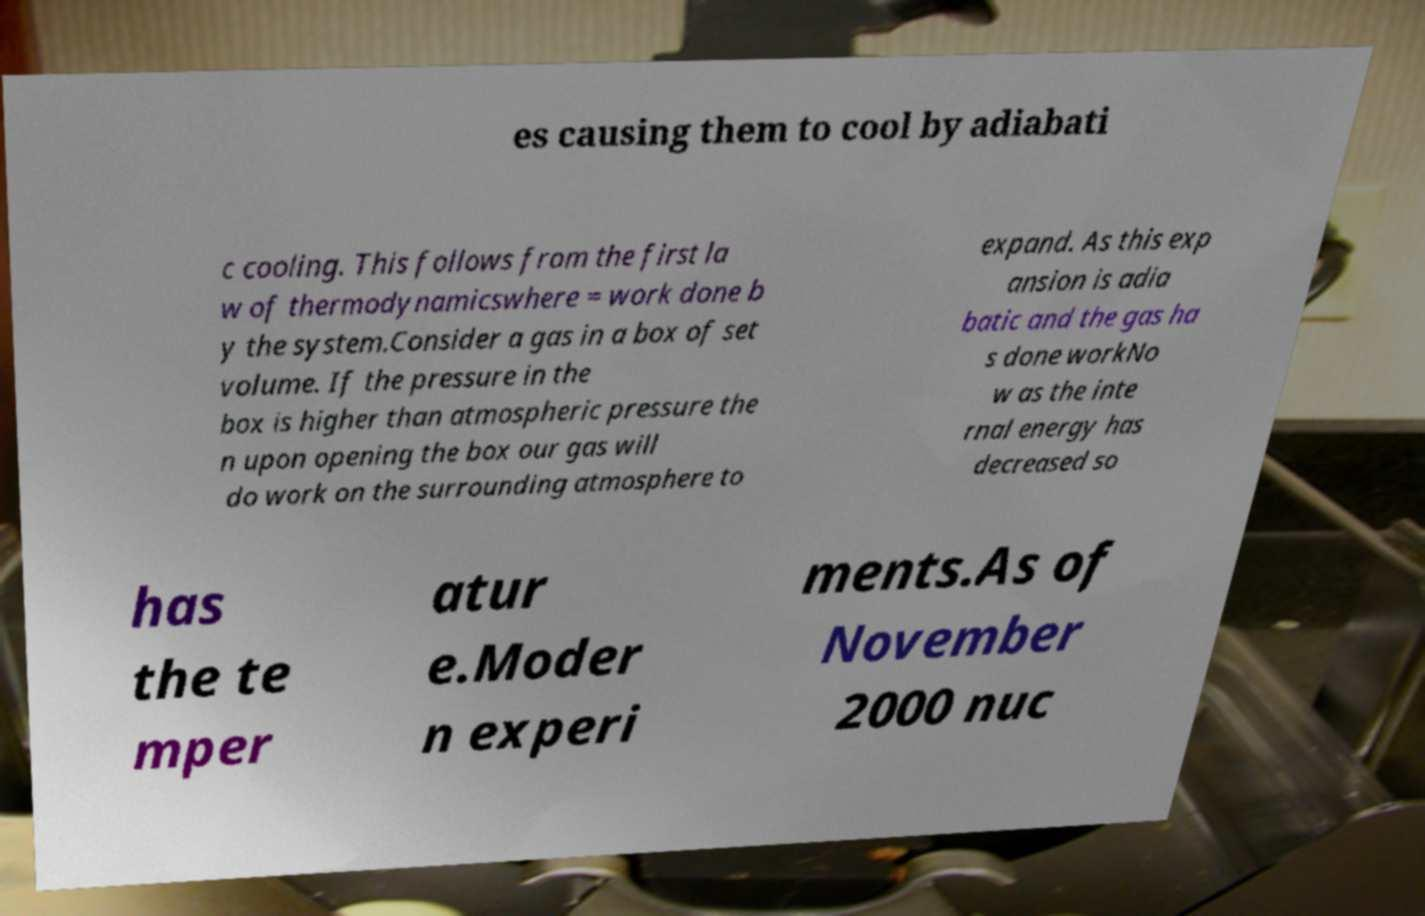There's text embedded in this image that I need extracted. Can you transcribe it verbatim? es causing them to cool by adiabati c cooling. This follows from the first la w of thermodynamicswhere = work done b y the system.Consider a gas in a box of set volume. If the pressure in the box is higher than atmospheric pressure the n upon opening the box our gas will do work on the surrounding atmosphere to expand. As this exp ansion is adia batic and the gas ha s done workNo w as the inte rnal energy has decreased so has the te mper atur e.Moder n experi ments.As of November 2000 nuc 